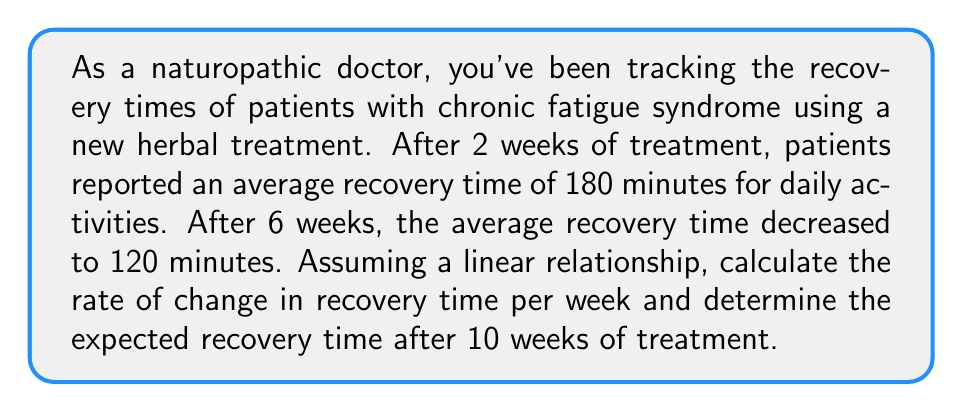Give your solution to this math problem. Let's approach this problem step-by-step using a linear equation:

1) First, we need to identify our variables:
   $x$ = number of weeks
   $y$ = recovery time in minutes

2) We have two points:
   $(2, 180)$ and $(6, 120)$

3) To find the rate of change (slope), we use the formula:
   
   $m = \frac{y_2 - y_1}{x_2 - x_1} = \frac{120 - 180}{6 - 2} = \frac{-60}{4} = -15$

   This means the recovery time is decreasing by 15 minutes per week.

4) Now we can form our linear equation using the point-slope form:
   
   $y - y_1 = m(x - x_1)$
   $y - 180 = -15(x - 2)$

5) Simplify:
   $y = -15x + 210$

6) To find the expected recovery time after 10 weeks, we substitute $x = 10$:
   
   $y = -15(10) + 210 = -150 + 210 = 60$

Therefore, after 10 weeks, the expected recovery time would be 60 minutes.
Answer: The rate of change in recovery time is -15 minutes per week, and the expected recovery time after 10 weeks of treatment is 60 minutes. 